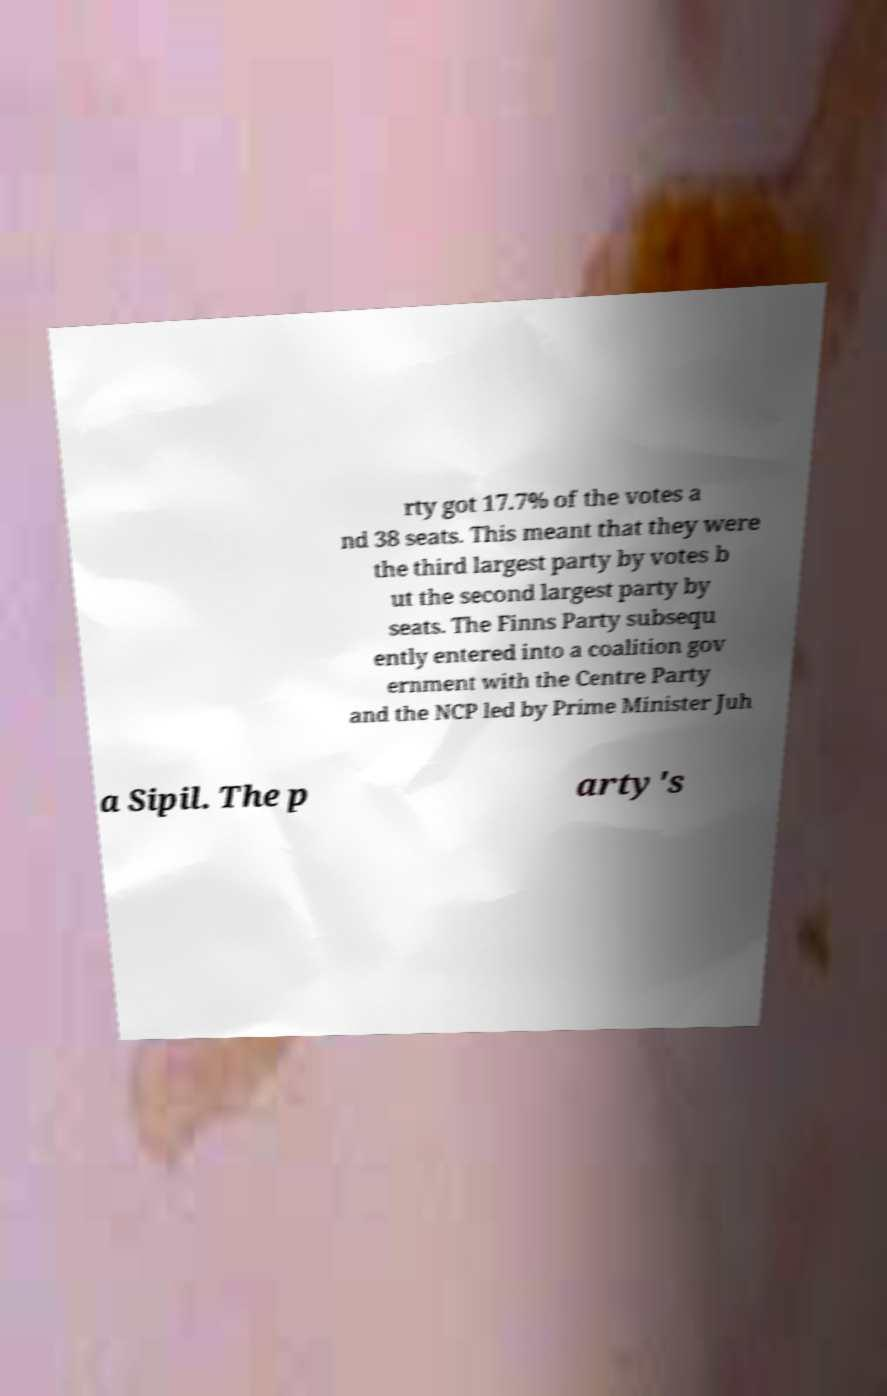For documentation purposes, I need the text within this image transcribed. Could you provide that? rty got 17.7% of the votes a nd 38 seats. This meant that they were the third largest party by votes b ut the second largest party by seats. The Finns Party subsequ ently entered into a coalition gov ernment with the Centre Party and the NCP led by Prime Minister Juh a Sipil. The p arty's 